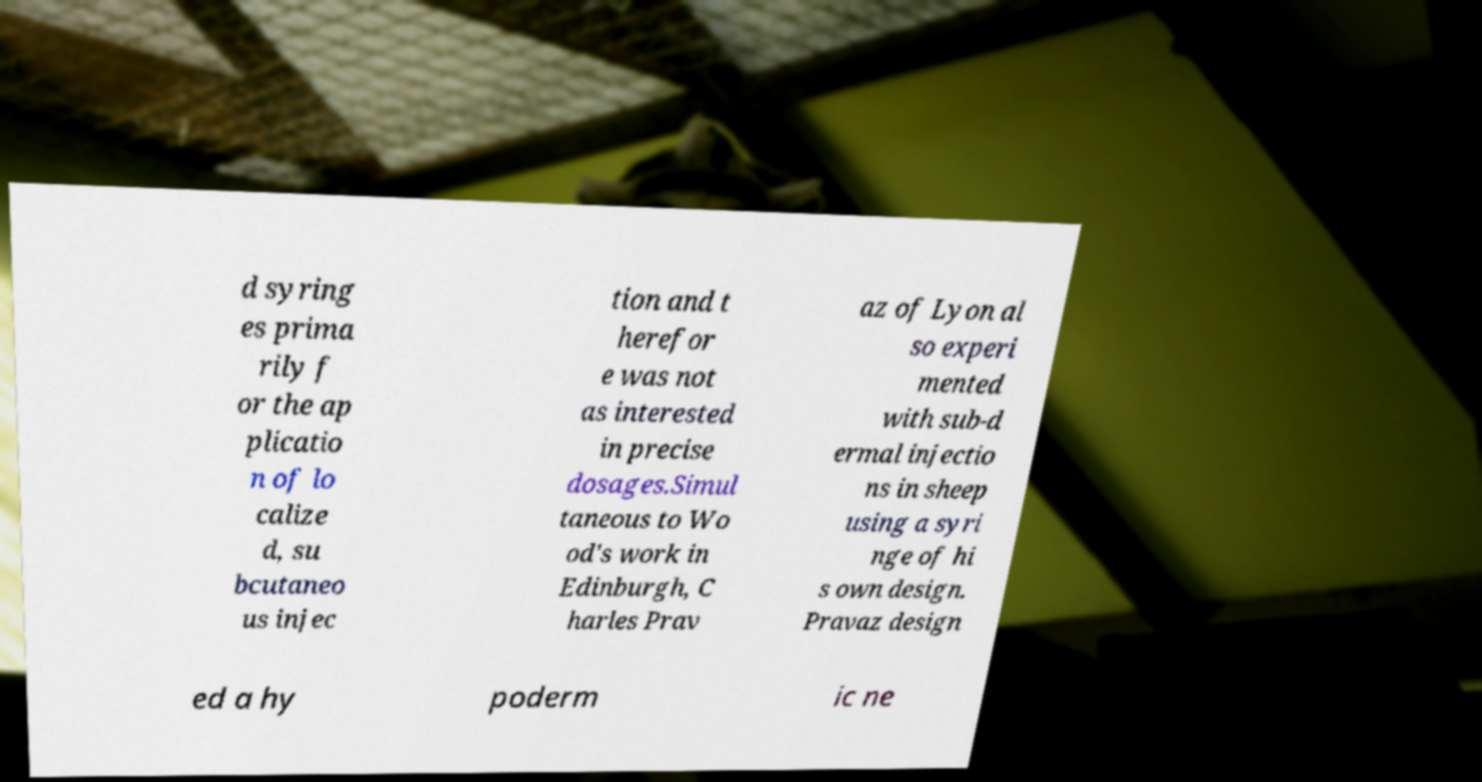Please identify and transcribe the text found in this image. d syring es prima rily f or the ap plicatio n of lo calize d, su bcutaneo us injec tion and t herefor e was not as interested in precise dosages.Simul taneous to Wo od's work in Edinburgh, C harles Prav az of Lyon al so experi mented with sub-d ermal injectio ns in sheep using a syri nge of hi s own design. Pravaz design ed a hy poderm ic ne 